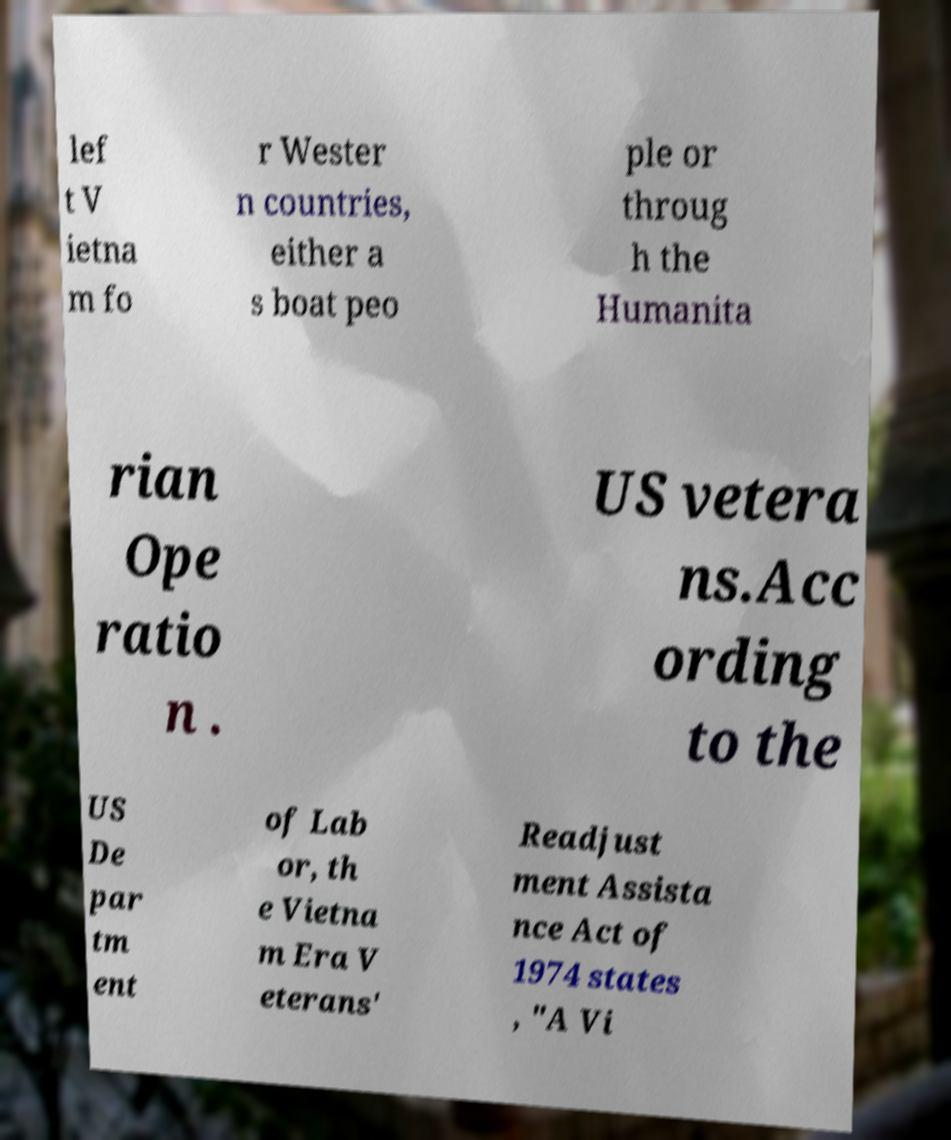I need the written content from this picture converted into text. Can you do that? lef t V ietna m fo r Wester n countries, either a s boat peo ple or throug h the Humanita rian Ope ratio n . US vetera ns.Acc ording to the US De par tm ent of Lab or, th e Vietna m Era V eterans' Readjust ment Assista nce Act of 1974 states , "A Vi 